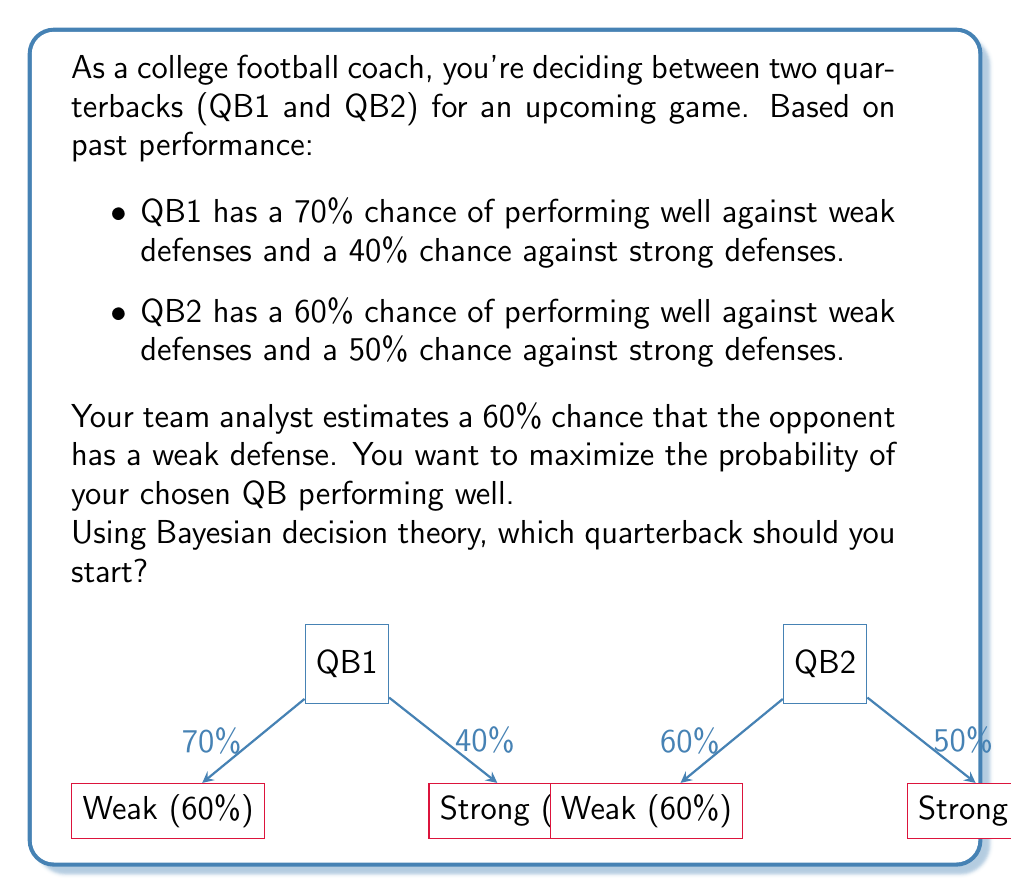Provide a solution to this math problem. Let's approach this problem using Bayesian decision theory:

1) Define our events:
   W: Opponent has a weak defense
   S: Opponent has a strong defense
   Q1: QB1 performs well
   Q2: QB2 performs well

2) Given probabilities:
   P(W) = 0.6, P(S) = 1 - P(W) = 0.4
   P(Q1|W) = 0.7, P(Q1|S) = 0.4
   P(Q2|W) = 0.6, P(Q2|S) = 0.5

3) Calculate the probability of each QB performing well using the law of total probability:

   For QB1:
   $$P(Q1) = P(Q1|W)P(W) + P(Q1|S)P(S)$$
   $$P(Q1) = 0.7 * 0.6 + 0.4 * 0.4 = 0.42 + 0.16 = 0.58$$

   For QB2:
   $$P(Q2) = P(Q2|W)P(W) + P(Q2|S)P(S)$$
   $$P(Q2) = 0.6 * 0.6 + 0.5 * 0.4 = 0.36 + 0.20 = 0.56$$

4) Compare the probabilities:
   P(Q1) = 0.58 > P(Q2) = 0.56

Therefore, QB1 has a higher probability of performing well overall.
Answer: Start QB1 